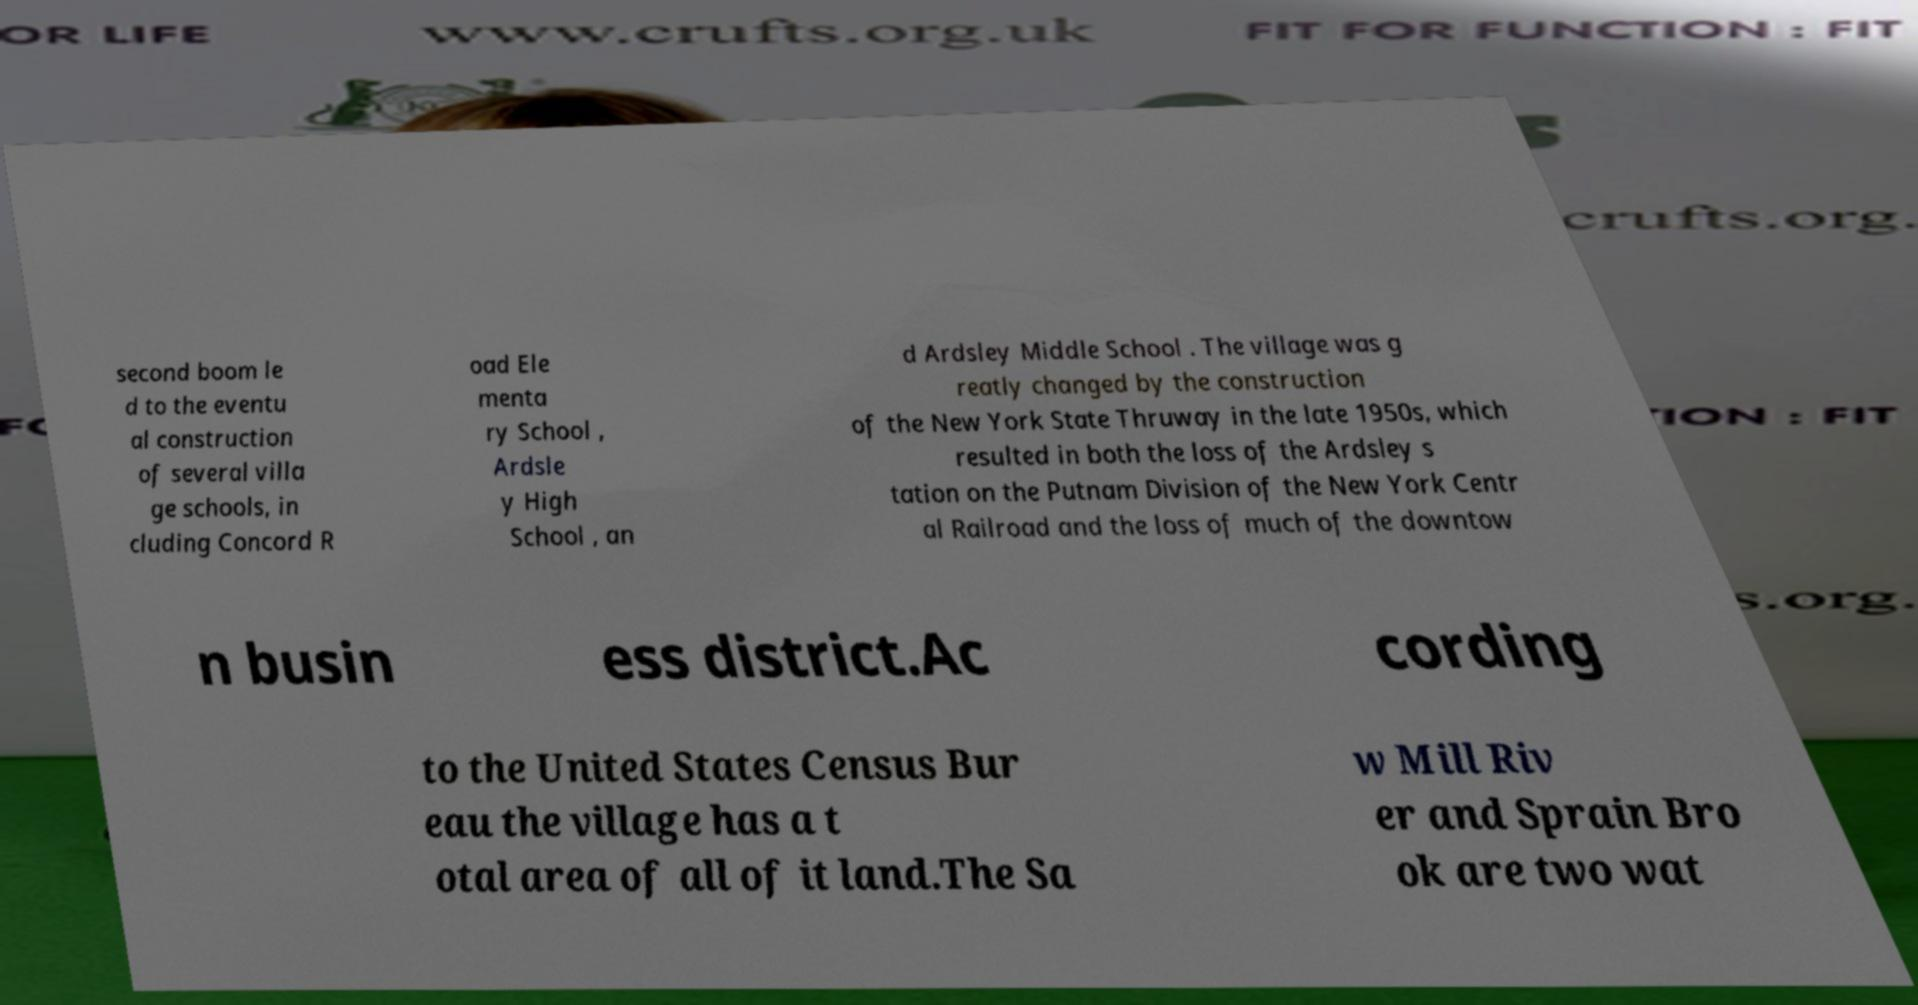For documentation purposes, I need the text within this image transcribed. Could you provide that? second boom le d to the eventu al construction of several villa ge schools, in cluding Concord R oad Ele menta ry School , Ardsle y High School , an d Ardsley Middle School . The village was g reatly changed by the construction of the New York State Thruway in the late 1950s, which resulted in both the loss of the Ardsley s tation on the Putnam Division of the New York Centr al Railroad and the loss of much of the downtow n busin ess district.Ac cording to the United States Census Bur eau the village has a t otal area of all of it land.The Sa w Mill Riv er and Sprain Bro ok are two wat 